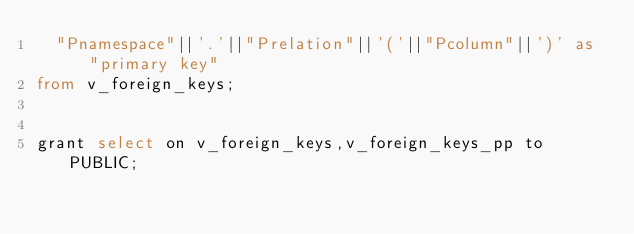Convert code to text. <code><loc_0><loc_0><loc_500><loc_500><_SQL_>  "Pnamespace"||'.'||"Prelation"||'('||"Pcolumn"||')' as "primary key"
from v_foreign_keys;


grant select on v_foreign_keys,v_foreign_keys_pp to PUBLIC;
</code> 